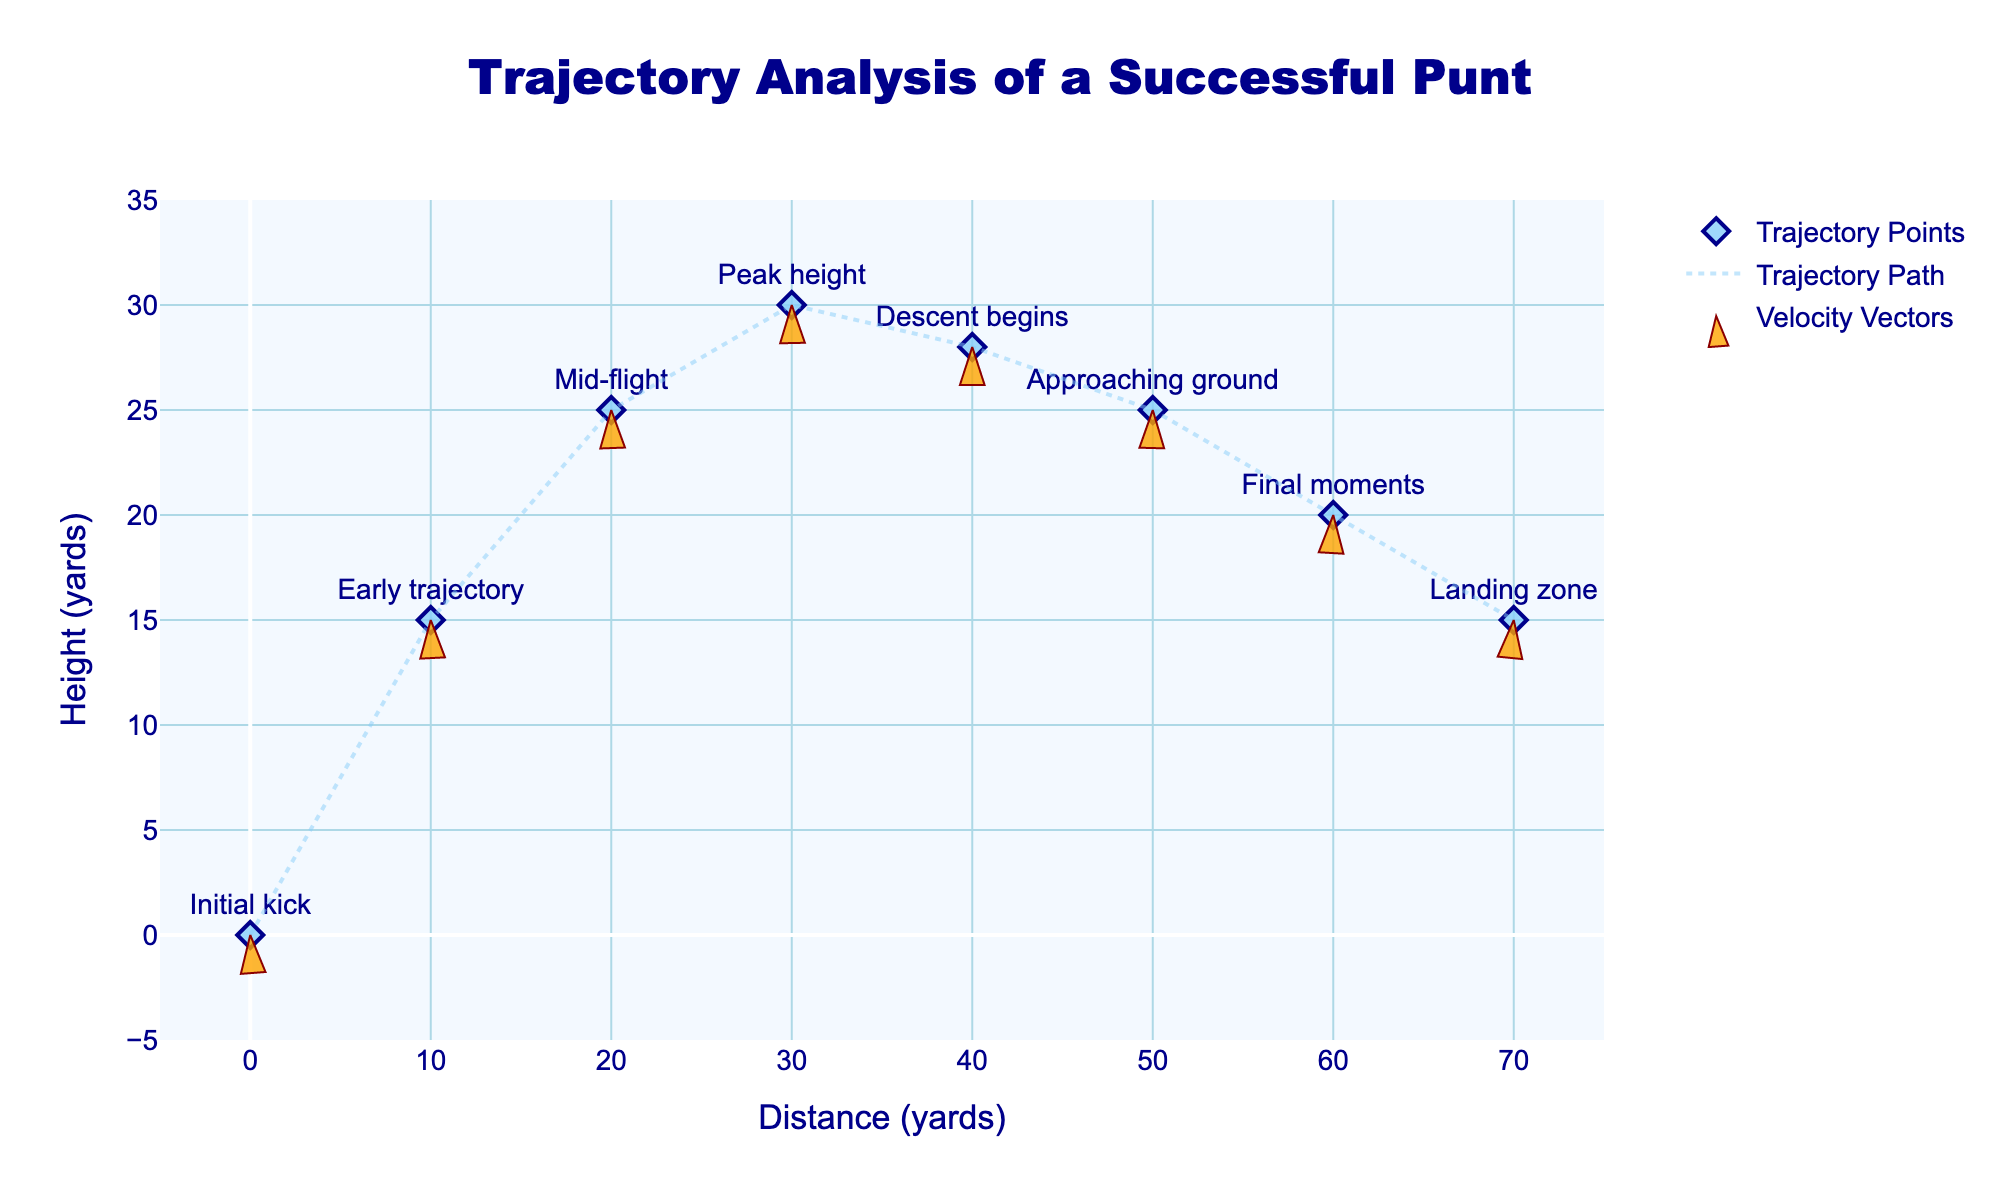What is the title of the figure? The title is displayed at the top center of the figure and is usually the most noticeable text in any plot.
Answer: "Trajectory Analysis of a Successful Punt" How many trajectory points are shown in the figure? Count the number of different labeled points in the plot. There are labels shown at each significant point on the trajectory path.
Answer: 8 At which marker does the velocity vector show the descent begins? Look for the label indicating "Descent begins" and check the x and y coordinates of the corresponding point.
Answer: "Descent begins" What is the range of the x-axis? Examine the bottom of the figure to see the minimum and maximum values of the x-axis.
Answer: -5 to 75 yards Compare the direction of the velocity vectors at "Initial kick" and "Landing zone". How are they different? Look at the angles of the arrowheads at these two points. The initial kick has an upward and forward direction, while the landing zone has a downward and forward direction.
Answer: The "Initial kick" vector points upwards, and the "Landing zone" vector points downwards What is the total horizontal distance covered by the punt? Sum the differences in the x-axis values from the "Initial kick" to the "Landing zone". (70 - 0 = 70 yards)
Answer: 70 yards What is the highest point reached during the punt, and at which x-coordinate does it occur? Identify the label "Peak height" and note its y and x values.
Answer: 30 yards at x = 30 How does the velocity vector magnitude change from "Initial kick" to "Final moments"? Compare the lengths of the vectors at these points, referring to their u and v components. The vector magnitudes tend to decrease over time.
Answer: The magnitude decreases from "Initial kick" to "Final moments" What phases of the punt have a positive y-component in their velocity vectors? Examine the v values in the data. Positive values are found from "Initial kick" to "Peak height".
Answer: From "Initial kick" to "Peak height" Which phase of the trajectory has the smallest u-component in its velocity vector? Look for the smallest u value in the data and identify its corresponding label.
Answer: "Final moments" with u = 35 